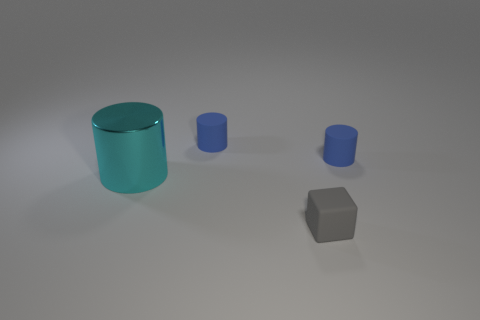Does the tiny cylinder that is on the left side of the small gray rubber cube have the same color as the cylinder that is to the right of the small gray rubber object?
Provide a short and direct response. Yes. Are there any tiny cylinders that are to the left of the small rubber thing that is in front of the cyan thing?
Ensure brevity in your answer.  Yes. How big is the metal cylinder?
Ensure brevity in your answer.  Large. How many things are either small matte objects or tiny red cylinders?
Offer a terse response. 3. Does the tiny object that is in front of the big metallic cylinder have the same material as the small blue thing that is on the left side of the tiny gray thing?
Offer a terse response. Yes. What number of cubes have the same size as the cyan cylinder?
Keep it short and to the point. 0. Is there any other thing that is the same size as the gray block?
Make the answer very short. Yes. There is a blue matte thing on the left side of the tiny gray rubber block; is it the same shape as the thing that is in front of the shiny object?
Provide a short and direct response. No. Is the number of rubber cylinders that are behind the gray thing the same as the number of cylinders that are in front of the metallic object?
Your response must be concise. No. Is there any other thing that has the same shape as the big cyan metal thing?
Your response must be concise. Yes. 